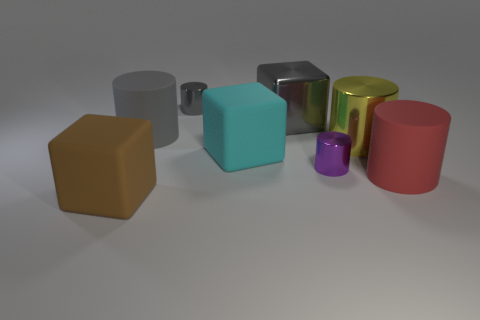How many other things are the same size as the cyan block?
Offer a very short reply. 5. There is a matte cylinder that is left of the red rubber cylinder; is it the same color as the big metal block?
Ensure brevity in your answer.  Yes. What is the size of the matte thing that is in front of the tiny purple object and on the left side of the yellow cylinder?
Offer a terse response. Large. How many tiny objects are shiny cylinders or red matte cylinders?
Give a very brief answer. 2. There is a small thing behind the large gray metal block; what shape is it?
Make the answer very short. Cylinder. How many gray metal objects are there?
Provide a succinct answer. 2. Is the gray block made of the same material as the cyan cube?
Offer a terse response. No. Are there more large yellow shiny objects that are on the right side of the large gray cube than large purple rubber cylinders?
Your response must be concise. Yes. How many things are purple objects or small metal cylinders on the right side of the cyan matte cube?
Your answer should be compact. 1. Are there more gray things on the left side of the big cyan thing than tiny gray cylinders that are left of the brown rubber block?
Make the answer very short. Yes. 